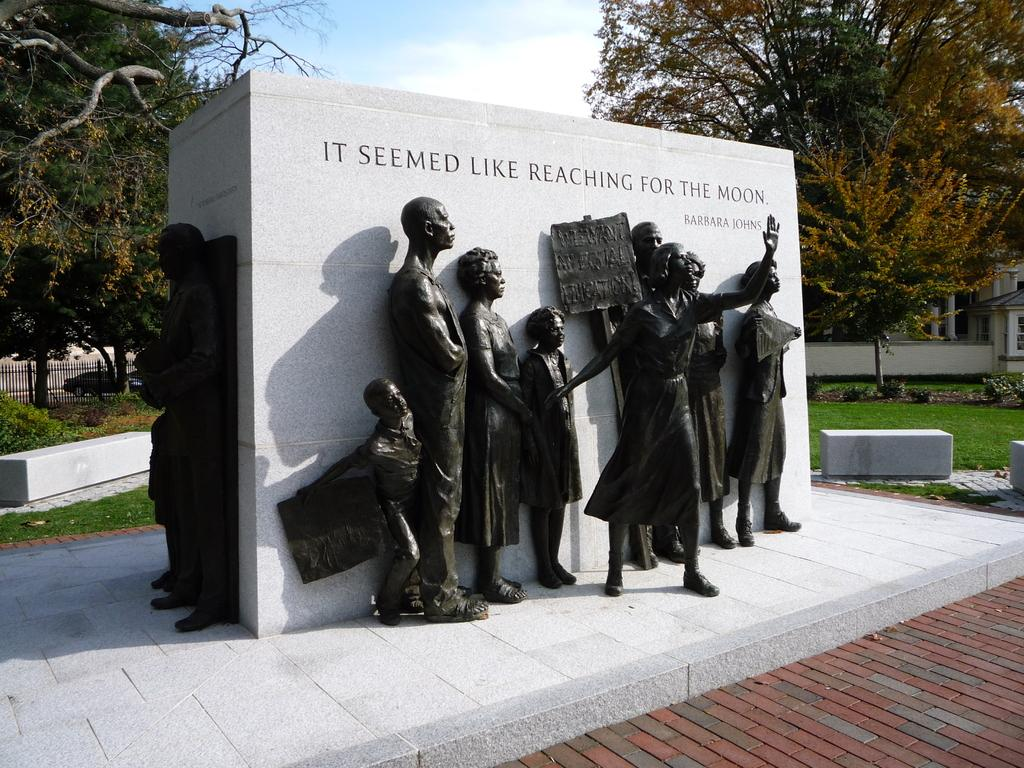What can be seen in the foreground of the image? There are sculptures in the foreground of the image. Where are the sculptures located? The sculptures are on a lawn. What is written on the stone in the foreground? There is text written on a stone in the foreground. What can be seen in the background of the image? There are trees and the sky visible in the background. What is the condition of the sky in the image? The sky is visible with clouds in the background. How many cakes are being pulled by the sculptures in the image? There are no cakes or sculptures pulling anything in the image. What type of rain can be seen falling on the trees in the image? There is no rain present in the image; it features sculptures on a lawn with trees and clouds in the background. 